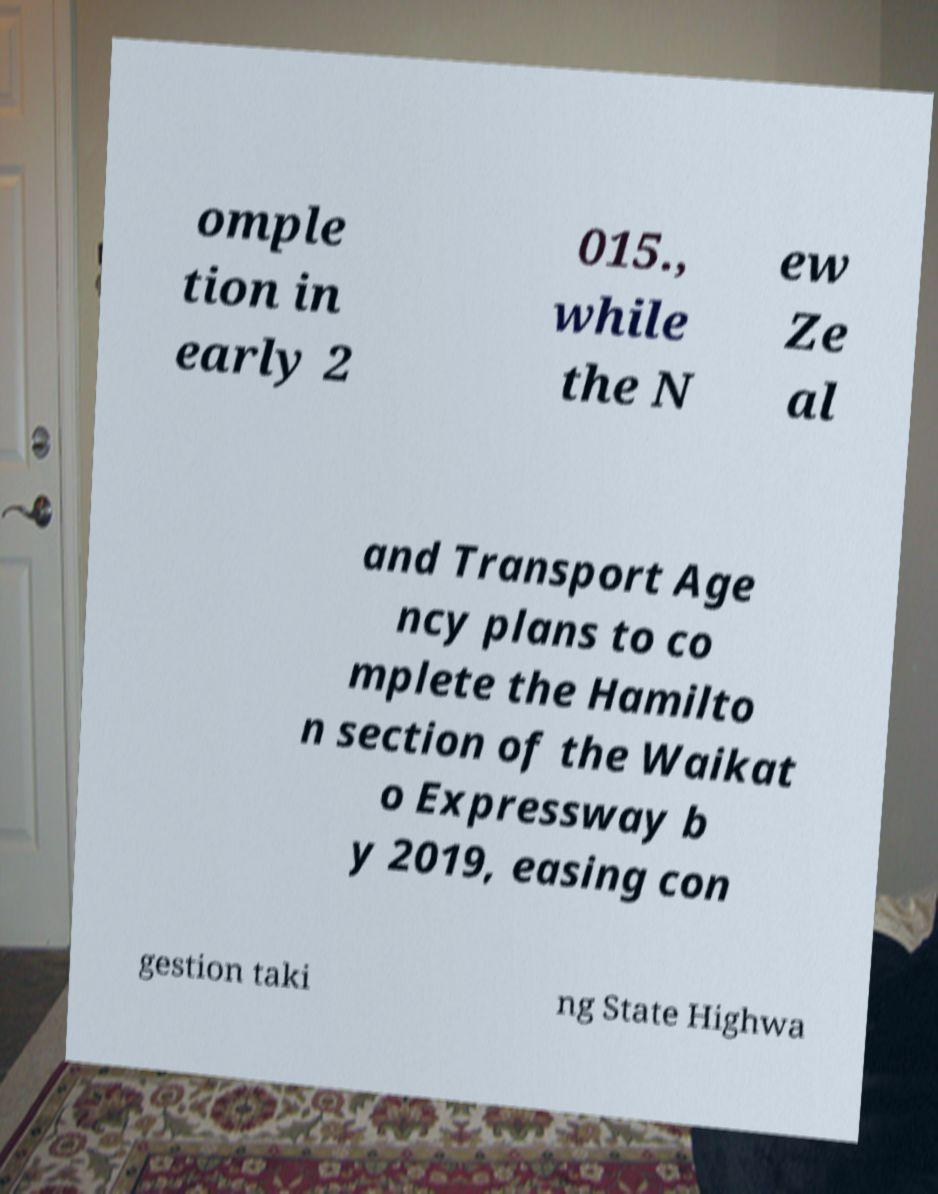Can you accurately transcribe the text from the provided image for me? omple tion in early 2 015., while the N ew Ze al and Transport Age ncy plans to co mplete the Hamilto n section of the Waikat o Expressway b y 2019, easing con gestion taki ng State Highwa 